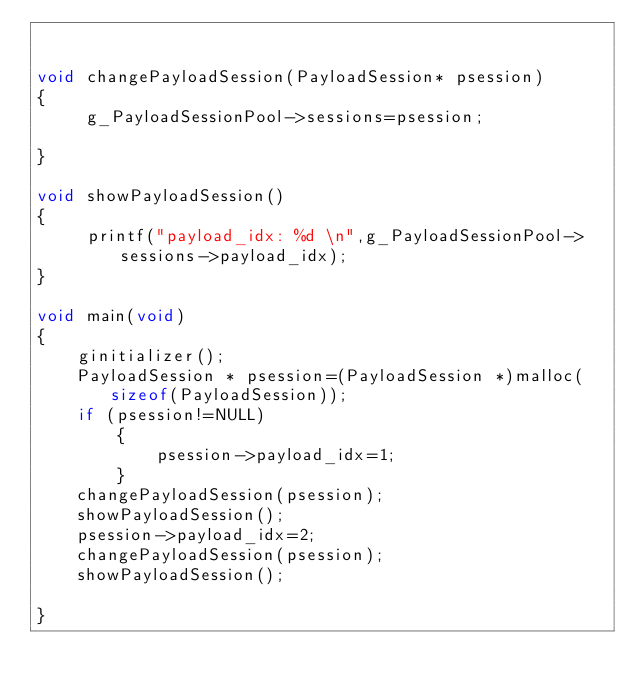Convert code to text. <code><loc_0><loc_0><loc_500><loc_500><_C_>

void changePayloadSession(PayloadSession* psession)
{
     g_PayloadSessionPool->sessions=psession;
   
}

void showPayloadSession()
{
     printf("payload_idx: %d \n",g_PayloadSessionPool->sessions->payload_idx);
}

void main(void)
{
    ginitializer(); 
    PayloadSession * psession=(PayloadSession *)malloc(sizeof(PayloadSession));
    if (psession!=NULL)
        {
            psession->payload_idx=1;
        }
    changePayloadSession(psession);
    showPayloadSession();
    psession->payload_idx=2;
    changePayloadSession(psession);
    showPayloadSession();
    
}
</code> 